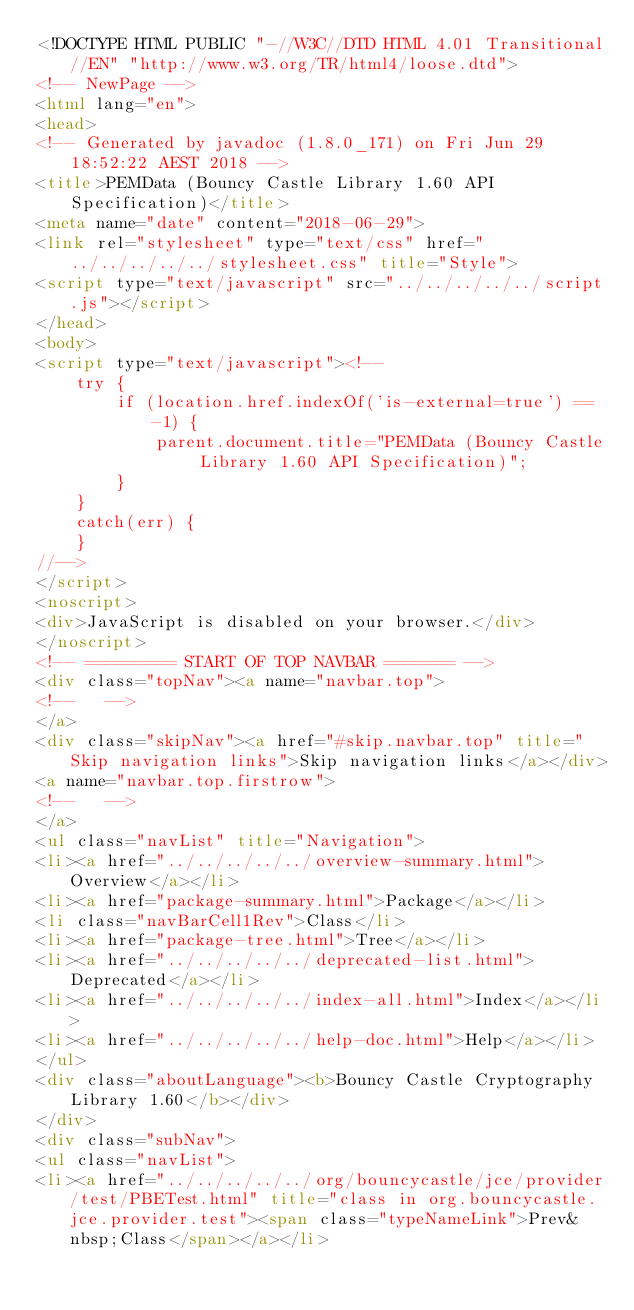<code> <loc_0><loc_0><loc_500><loc_500><_HTML_><!DOCTYPE HTML PUBLIC "-//W3C//DTD HTML 4.01 Transitional//EN" "http://www.w3.org/TR/html4/loose.dtd">
<!-- NewPage -->
<html lang="en">
<head>
<!-- Generated by javadoc (1.8.0_171) on Fri Jun 29 18:52:22 AEST 2018 -->
<title>PEMData (Bouncy Castle Library 1.60 API Specification)</title>
<meta name="date" content="2018-06-29">
<link rel="stylesheet" type="text/css" href="../../../../../stylesheet.css" title="Style">
<script type="text/javascript" src="../../../../../script.js"></script>
</head>
<body>
<script type="text/javascript"><!--
    try {
        if (location.href.indexOf('is-external=true') == -1) {
            parent.document.title="PEMData (Bouncy Castle Library 1.60 API Specification)";
        }
    }
    catch(err) {
    }
//-->
</script>
<noscript>
<div>JavaScript is disabled on your browser.</div>
</noscript>
<!-- ========= START OF TOP NAVBAR ======= -->
<div class="topNav"><a name="navbar.top">
<!--   -->
</a>
<div class="skipNav"><a href="#skip.navbar.top" title="Skip navigation links">Skip navigation links</a></div>
<a name="navbar.top.firstrow">
<!--   -->
</a>
<ul class="navList" title="Navigation">
<li><a href="../../../../../overview-summary.html">Overview</a></li>
<li><a href="package-summary.html">Package</a></li>
<li class="navBarCell1Rev">Class</li>
<li><a href="package-tree.html">Tree</a></li>
<li><a href="../../../../../deprecated-list.html">Deprecated</a></li>
<li><a href="../../../../../index-all.html">Index</a></li>
<li><a href="../../../../../help-doc.html">Help</a></li>
</ul>
<div class="aboutLanguage"><b>Bouncy Castle Cryptography Library 1.60</b></div>
</div>
<div class="subNav">
<ul class="navList">
<li><a href="../../../../../org/bouncycastle/jce/provider/test/PBETest.html" title="class in org.bouncycastle.jce.provider.test"><span class="typeNameLink">Prev&nbsp;Class</span></a></li></code> 